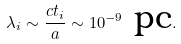Convert formula to latex. <formula><loc_0><loc_0><loc_500><loc_500>\lambda _ { i } \sim \frac { c t _ { i } } { a } \sim 1 0 ^ { - 9 } \text { pc} .</formula> 